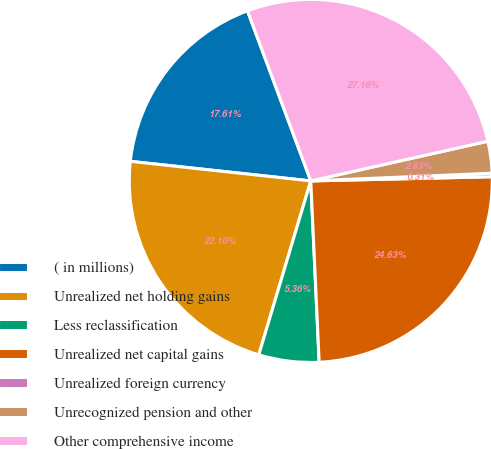Convert chart. <chart><loc_0><loc_0><loc_500><loc_500><pie_chart><fcel>( in millions)<fcel>Unrealized net holding gains<fcel>Less reclassification<fcel>Unrealized net capital gains<fcel>Unrealized foreign currency<fcel>Unrecognized pension and other<fcel>Other comprehensive income<nl><fcel>17.61%<fcel>22.1%<fcel>5.36%<fcel>24.63%<fcel>0.31%<fcel>2.83%<fcel>27.16%<nl></chart> 